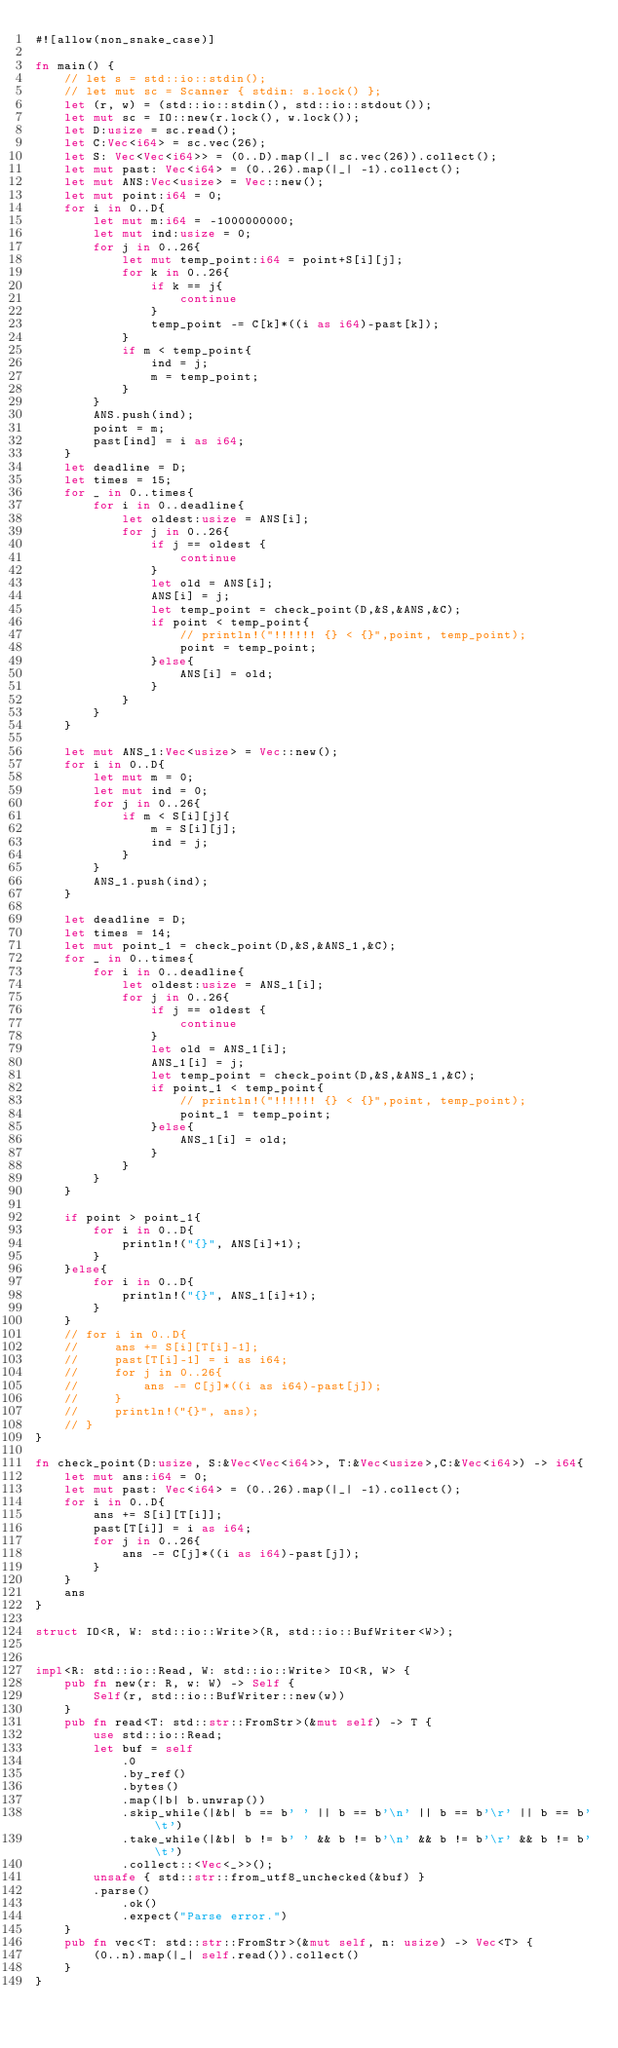Convert code to text. <code><loc_0><loc_0><loc_500><loc_500><_Rust_>#![allow(non_snake_case)]

fn main() {
    // let s = std::io::stdin();
    // let mut sc = Scanner { stdin: s.lock() };
    let (r, w) = (std::io::stdin(), std::io::stdout());
    let mut sc = IO::new(r.lock(), w.lock());
    let D:usize = sc.read();
    let C:Vec<i64> = sc.vec(26);
    let S: Vec<Vec<i64>> = (0..D).map(|_| sc.vec(26)).collect();
    let mut past: Vec<i64> = (0..26).map(|_| -1).collect();
    let mut ANS:Vec<usize> = Vec::new();
    let mut point:i64 = 0;
    for i in 0..D{
        let mut m:i64 = -1000000000;
        let mut ind:usize = 0;
        for j in 0..26{
            let mut temp_point:i64 = point+S[i][j];
            for k in 0..26{
                if k == j{
                    continue
                }
                temp_point -= C[k]*((i as i64)-past[k]);
            }
            if m < temp_point{
                ind = j;
                m = temp_point;
            }
        }
        ANS.push(ind);
        point = m;
        past[ind] = i as i64;
    }
    let deadline = D;
    let times = 15;
    for _ in 0..times{
        for i in 0..deadline{
            let oldest:usize = ANS[i];
            for j in 0..26{
                if j == oldest {
                    continue
                }
                let old = ANS[i];
                ANS[i] = j;
                let temp_point = check_point(D,&S,&ANS,&C);
                if point < temp_point{
                    // println!("!!!!!! {} < {}",point, temp_point);
                    point = temp_point;
                }else{
                    ANS[i] = old;
                }
            }
        }
    }

    let mut ANS_1:Vec<usize> = Vec::new();
    for i in 0..D{
        let mut m = 0;
        let mut ind = 0;
        for j in 0..26{
            if m < S[i][j]{
                m = S[i][j];
                ind = j;
            }
        }
        ANS_1.push(ind);
    }

    let deadline = D;
    let times = 14;
    let mut point_1 = check_point(D,&S,&ANS_1,&C);
    for _ in 0..times{
        for i in 0..deadline{
            let oldest:usize = ANS_1[i];
            for j in 0..26{
                if j == oldest {
                    continue
                }
                let old = ANS_1[i];
                ANS_1[i] = j;
                let temp_point = check_point(D,&S,&ANS_1,&C);
                if point_1 < temp_point{
                    // println!("!!!!!! {} < {}",point, temp_point);
                    point_1 = temp_point;
                }else{
                    ANS_1[i] = old;
                }
            }
        }
    }
    
    if point > point_1{
        for i in 0..D{
            println!("{}", ANS[i]+1);
        }
    }else{
        for i in 0..D{
            println!("{}", ANS_1[i]+1);
        }        
    }
    // for i in 0..D{
    //     ans += S[i][T[i]-1];
    //     past[T[i]-1] = i as i64;
    //     for j in 0..26{
    //         ans -= C[j]*((i as i64)-past[j]);
    //     }
    //     println!("{}", ans);
    // }
}

fn check_point(D:usize, S:&Vec<Vec<i64>>, T:&Vec<usize>,C:&Vec<i64>) -> i64{
    let mut ans:i64 = 0;
    let mut past: Vec<i64> = (0..26).map(|_| -1).collect();
    for i in 0..D{
        ans += S[i][T[i]];
        past[T[i]] = i as i64;
        for j in 0..26{
            ans -= C[j]*((i as i64)-past[j]);
        }
    }
    ans
}

struct IO<R, W: std::io::Write>(R, std::io::BufWriter<W>);


impl<R: std::io::Read, W: std::io::Write> IO<R, W> {
    pub fn new(r: R, w: W) -> Self {
        Self(r, std::io::BufWriter::new(w))
    }
    pub fn read<T: std::str::FromStr>(&mut self) -> T {
        use std::io::Read;
        let buf = self
            .0
            .by_ref()
            .bytes()
            .map(|b| b.unwrap())
            .skip_while(|&b| b == b' ' || b == b'\n' || b == b'\r' || b == b'\t')
            .take_while(|&b| b != b' ' && b != b'\n' && b != b'\r' && b != b'\t')
            .collect::<Vec<_>>();
        unsafe { std::str::from_utf8_unchecked(&buf) }
        .parse()
            .ok()
            .expect("Parse error.")
    }
    pub fn vec<T: std::str::FromStr>(&mut self, n: usize) -> Vec<T> {
        (0..n).map(|_| self.read()).collect()
    }
}



</code> 